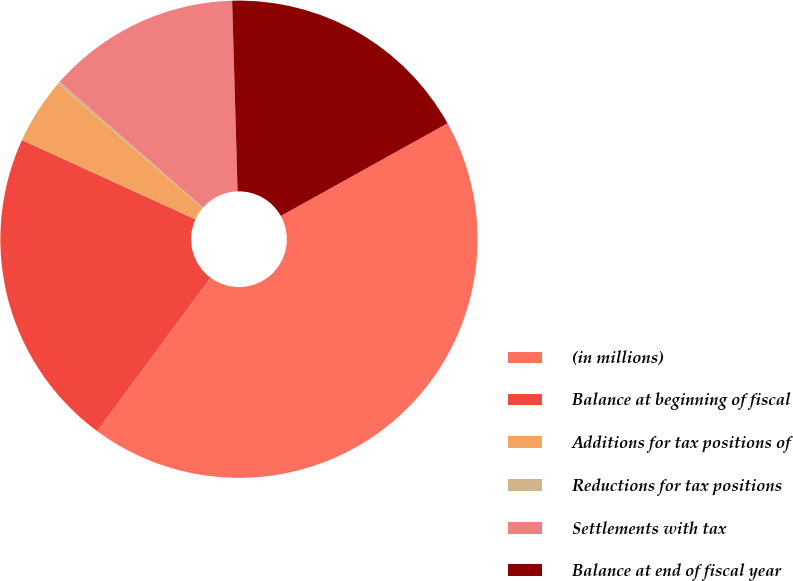Convert chart. <chart><loc_0><loc_0><loc_500><loc_500><pie_chart><fcel>(in millions)<fcel>Balance at beginning of fiscal<fcel>Additions for tax positions of<fcel>Reductions for tax positions<fcel>Settlements with tax<fcel>Balance at end of fiscal year<nl><fcel>43.2%<fcel>21.69%<fcel>4.47%<fcel>0.17%<fcel>13.08%<fcel>17.38%<nl></chart> 